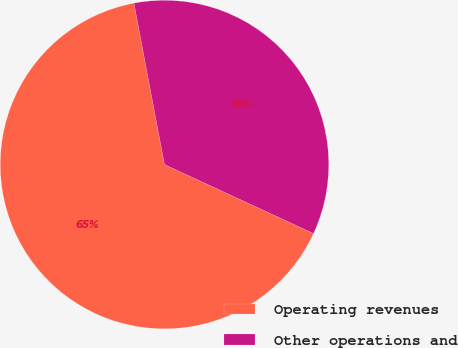Convert chart. <chart><loc_0><loc_0><loc_500><loc_500><pie_chart><fcel>Operating revenues<fcel>Other operations and<nl><fcel>65.12%<fcel>34.88%<nl></chart> 